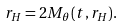Convert formula to latex. <formula><loc_0><loc_0><loc_500><loc_500>r _ { H } = 2 M _ { \theta } ( t , r _ { H } ) .</formula> 